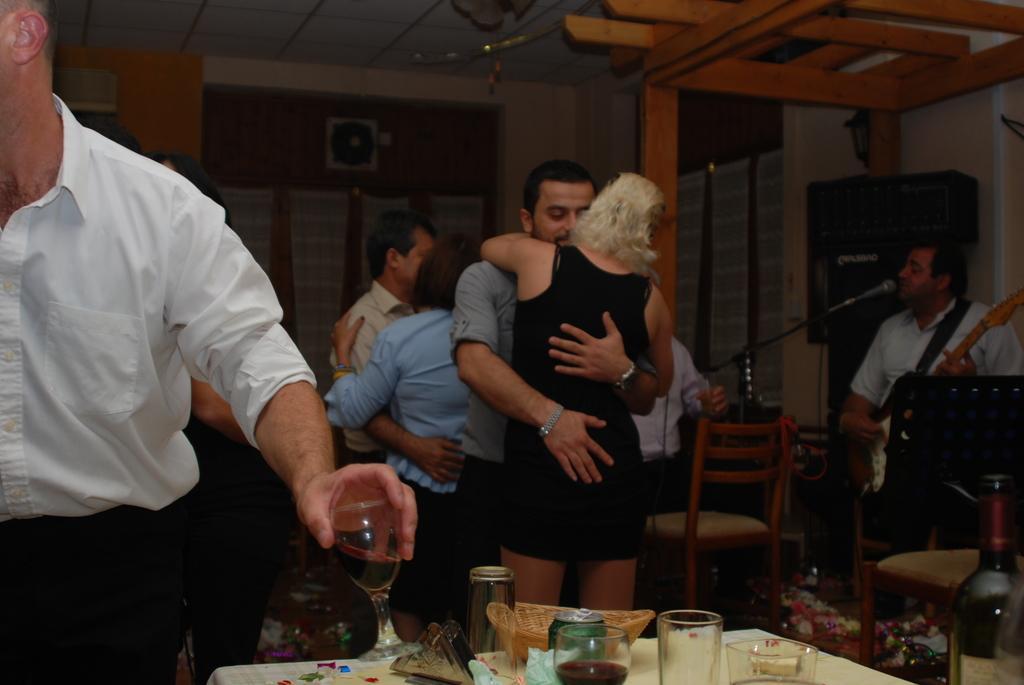Could you give a brief overview of what you see in this image? In the middle of women and men are hugging each other in the right a man is standing and singing in the microphone he is also holding a guitar in his hands in the left a man is holding a wine glass in his hands and he wears white color shirt there are wine glasses on the table. 